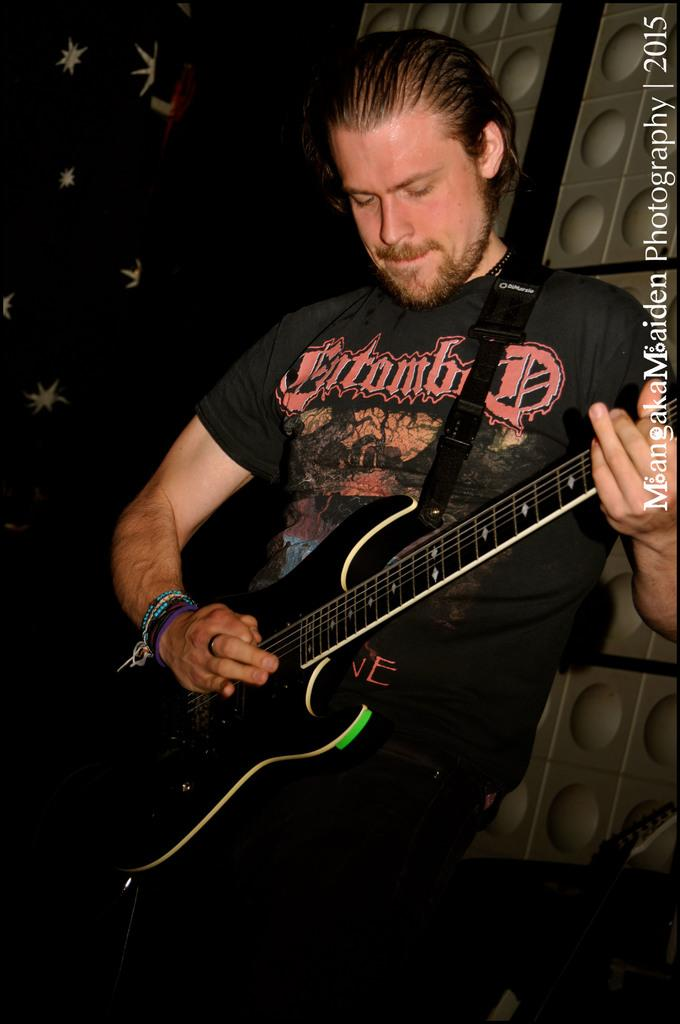Who is the main subject in the image? There is a man in the image. What is the man holding in the image? The man is holding a guitar. What is the man doing with the guitar? The man is playing the guitar. What is the man leaning against in the image? The man is leaning against a wall. What type of food is the man eating in the image? There is no food present in the image; the man is playing a guitar while leaning against a wall. 